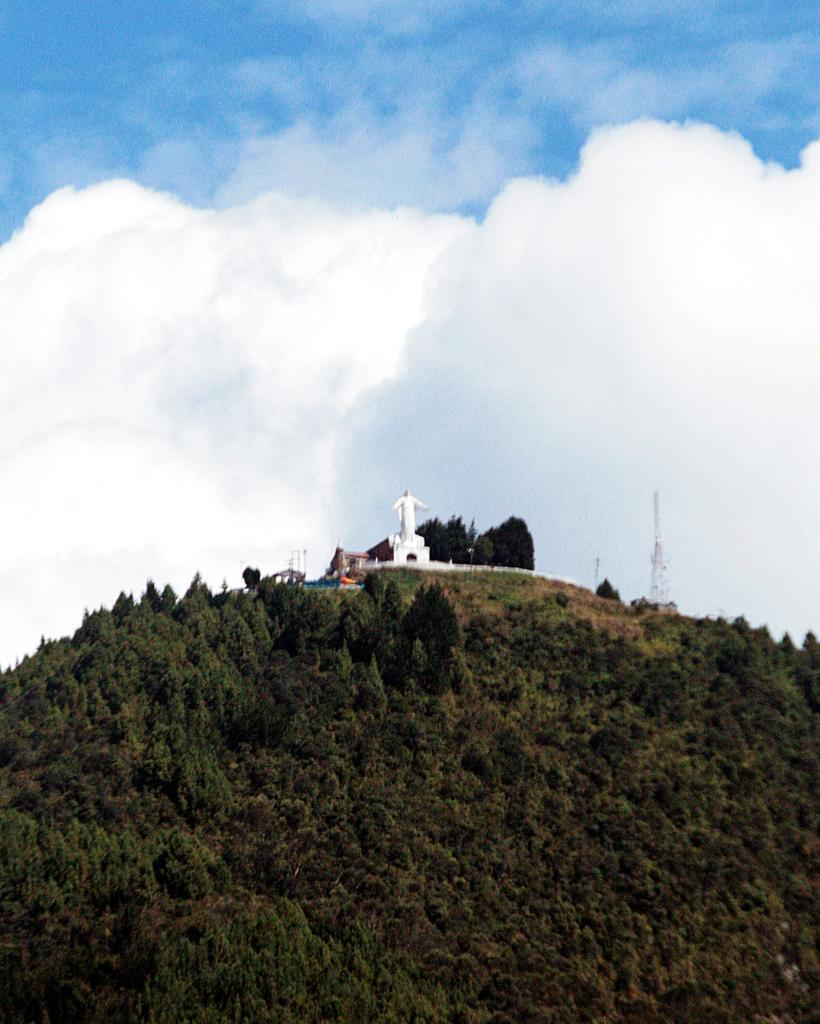What color is the sky in the image? The sky is blue in the image. What is the main subject in the middle of the image? There is a statue in the middle of the image. What type of vegetation is present at the bottom of the image? Greenery is present at the bottom of the image. Can you describe the natural elements in the image? Trees are visible in the image. What type of polish is being applied to the statue in the image? There is no indication in the image that any polish is being applied to the statue. Can you see any squirrels climbing the trees in the image? There are no squirrels visible in the image; only trees are present. 